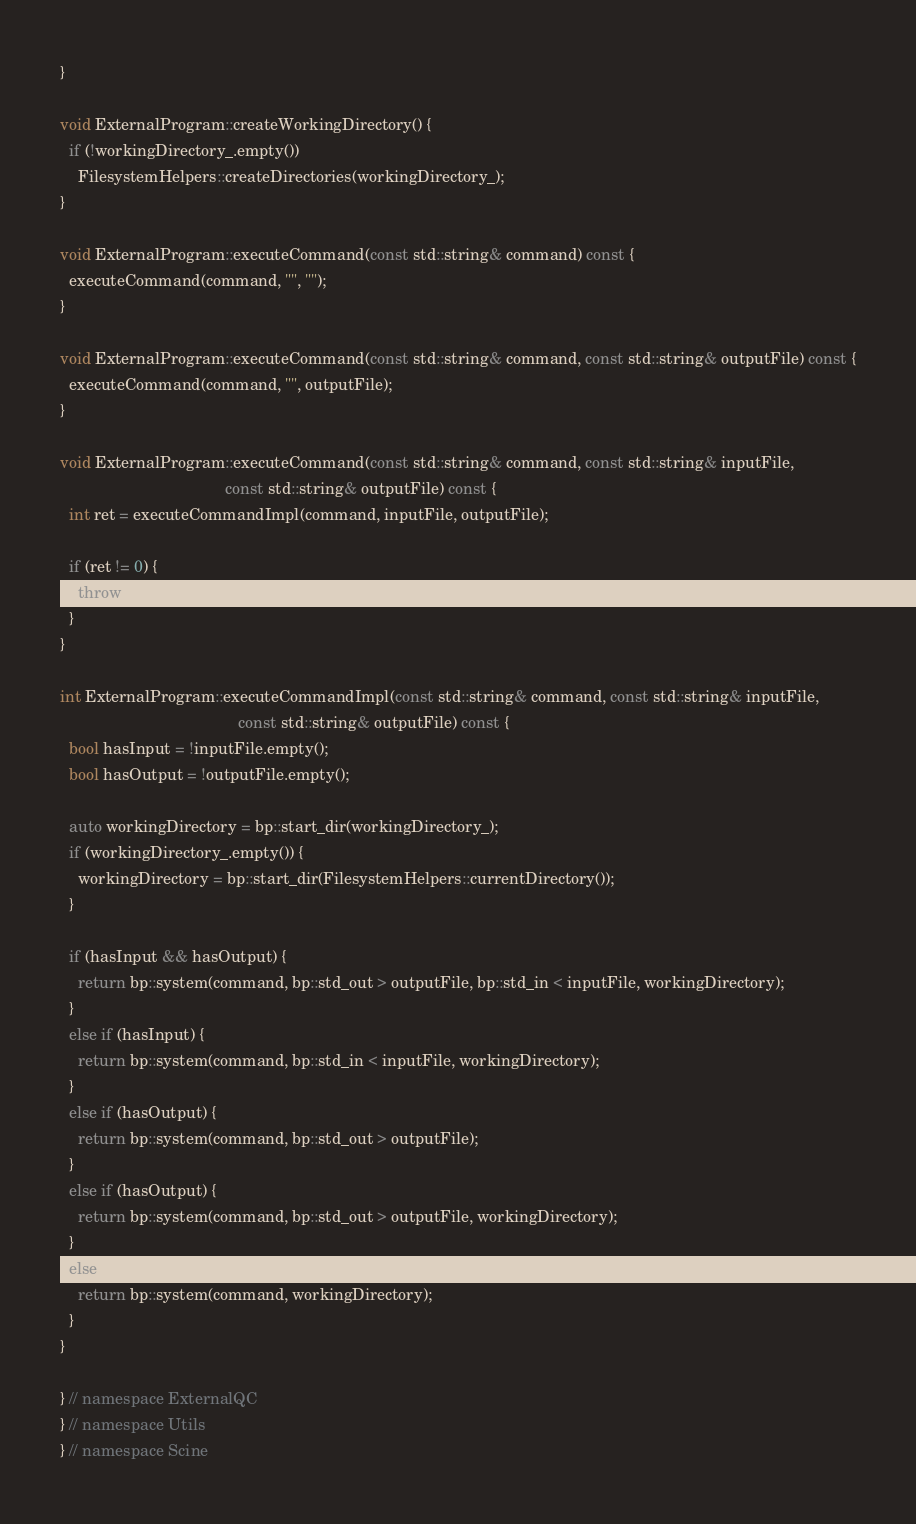<code> <loc_0><loc_0><loc_500><loc_500><_C++_>}

void ExternalProgram::createWorkingDirectory() {
  if (!workingDirectory_.empty())
    FilesystemHelpers::createDirectories(workingDirectory_);
}

void ExternalProgram::executeCommand(const std::string& command) const {
  executeCommand(command, "", "");
}

void ExternalProgram::executeCommand(const std::string& command, const std::string& outputFile) const {
  executeCommand(command, "", outputFile);
}

void ExternalProgram::executeCommand(const std::string& command, const std::string& inputFile,
                                     const std::string& outputFile) const {
  int ret = executeCommandImpl(command, inputFile, outputFile);

  if (ret != 0) {
    throw UnsuccessfulSystemCommand(command, inputFile, outputFile);
  }
}

int ExternalProgram::executeCommandImpl(const std::string& command, const std::string& inputFile,
                                        const std::string& outputFile) const {
  bool hasInput = !inputFile.empty();
  bool hasOutput = !outputFile.empty();

  auto workingDirectory = bp::start_dir(workingDirectory_);
  if (workingDirectory_.empty()) {
    workingDirectory = bp::start_dir(FilesystemHelpers::currentDirectory());
  }

  if (hasInput && hasOutput) {
    return bp::system(command, bp::std_out > outputFile, bp::std_in < inputFile, workingDirectory);
  }
  else if (hasInput) {
    return bp::system(command, bp::std_in < inputFile, workingDirectory);
  }
  else if (hasOutput) {
    return bp::system(command, bp::std_out > outputFile);
  }
  else if (hasOutput) {
    return bp::system(command, bp::std_out > outputFile, workingDirectory);
  }
  else {
    return bp::system(command, workingDirectory);
  }
}

} // namespace ExternalQC
} // namespace Utils
} // namespace Scine</code> 